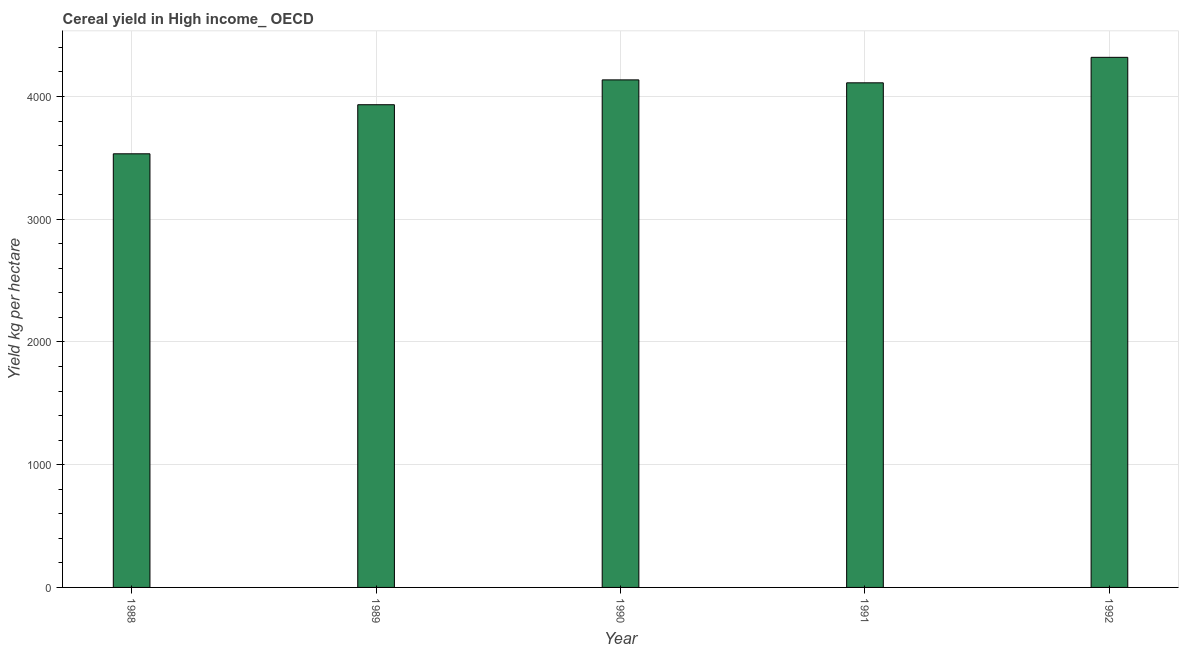Does the graph contain any zero values?
Your response must be concise. No. What is the title of the graph?
Ensure brevity in your answer.  Cereal yield in High income_ OECD. What is the label or title of the Y-axis?
Offer a terse response. Yield kg per hectare. What is the cereal yield in 1991?
Offer a very short reply. 4111.54. Across all years, what is the maximum cereal yield?
Ensure brevity in your answer.  4319.23. Across all years, what is the minimum cereal yield?
Your answer should be compact. 3533.18. In which year was the cereal yield maximum?
Your answer should be very brief. 1992. In which year was the cereal yield minimum?
Your response must be concise. 1988. What is the sum of the cereal yield?
Provide a short and direct response. 2.00e+04. What is the difference between the cereal yield in 1988 and 1989?
Give a very brief answer. -399.82. What is the average cereal yield per year?
Your answer should be very brief. 4006.48. What is the median cereal yield?
Keep it short and to the point. 4111.54. In how many years, is the cereal yield greater than 4200 kg per hectare?
Give a very brief answer. 1. What is the ratio of the cereal yield in 1991 to that in 1992?
Keep it short and to the point. 0.95. Is the cereal yield in 1990 less than that in 1992?
Your answer should be very brief. Yes. What is the difference between the highest and the second highest cereal yield?
Your answer should be very brief. 183.78. What is the difference between the highest and the lowest cereal yield?
Provide a succinct answer. 786.04. How many bars are there?
Ensure brevity in your answer.  5. Are all the bars in the graph horizontal?
Make the answer very short. No. How many years are there in the graph?
Your answer should be compact. 5. Are the values on the major ticks of Y-axis written in scientific E-notation?
Offer a terse response. No. What is the Yield kg per hectare of 1988?
Offer a terse response. 3533.18. What is the Yield kg per hectare of 1989?
Keep it short and to the point. 3933.01. What is the Yield kg per hectare in 1990?
Offer a terse response. 4135.44. What is the Yield kg per hectare in 1991?
Provide a succinct answer. 4111.54. What is the Yield kg per hectare in 1992?
Provide a succinct answer. 4319.23. What is the difference between the Yield kg per hectare in 1988 and 1989?
Provide a succinct answer. -399.82. What is the difference between the Yield kg per hectare in 1988 and 1990?
Provide a short and direct response. -602.26. What is the difference between the Yield kg per hectare in 1988 and 1991?
Your answer should be compact. -578.35. What is the difference between the Yield kg per hectare in 1988 and 1992?
Give a very brief answer. -786.04. What is the difference between the Yield kg per hectare in 1989 and 1990?
Provide a succinct answer. -202.44. What is the difference between the Yield kg per hectare in 1989 and 1991?
Ensure brevity in your answer.  -178.53. What is the difference between the Yield kg per hectare in 1989 and 1992?
Provide a succinct answer. -386.22. What is the difference between the Yield kg per hectare in 1990 and 1991?
Offer a terse response. 23.91. What is the difference between the Yield kg per hectare in 1990 and 1992?
Keep it short and to the point. -183.79. What is the difference between the Yield kg per hectare in 1991 and 1992?
Your answer should be compact. -207.69. What is the ratio of the Yield kg per hectare in 1988 to that in 1989?
Give a very brief answer. 0.9. What is the ratio of the Yield kg per hectare in 1988 to that in 1990?
Ensure brevity in your answer.  0.85. What is the ratio of the Yield kg per hectare in 1988 to that in 1991?
Make the answer very short. 0.86. What is the ratio of the Yield kg per hectare in 1988 to that in 1992?
Keep it short and to the point. 0.82. What is the ratio of the Yield kg per hectare in 1989 to that in 1990?
Provide a short and direct response. 0.95. What is the ratio of the Yield kg per hectare in 1989 to that in 1991?
Your answer should be compact. 0.96. What is the ratio of the Yield kg per hectare in 1989 to that in 1992?
Keep it short and to the point. 0.91. What is the ratio of the Yield kg per hectare in 1990 to that in 1991?
Give a very brief answer. 1.01. What is the ratio of the Yield kg per hectare in 1990 to that in 1992?
Your response must be concise. 0.96. What is the ratio of the Yield kg per hectare in 1991 to that in 1992?
Make the answer very short. 0.95. 